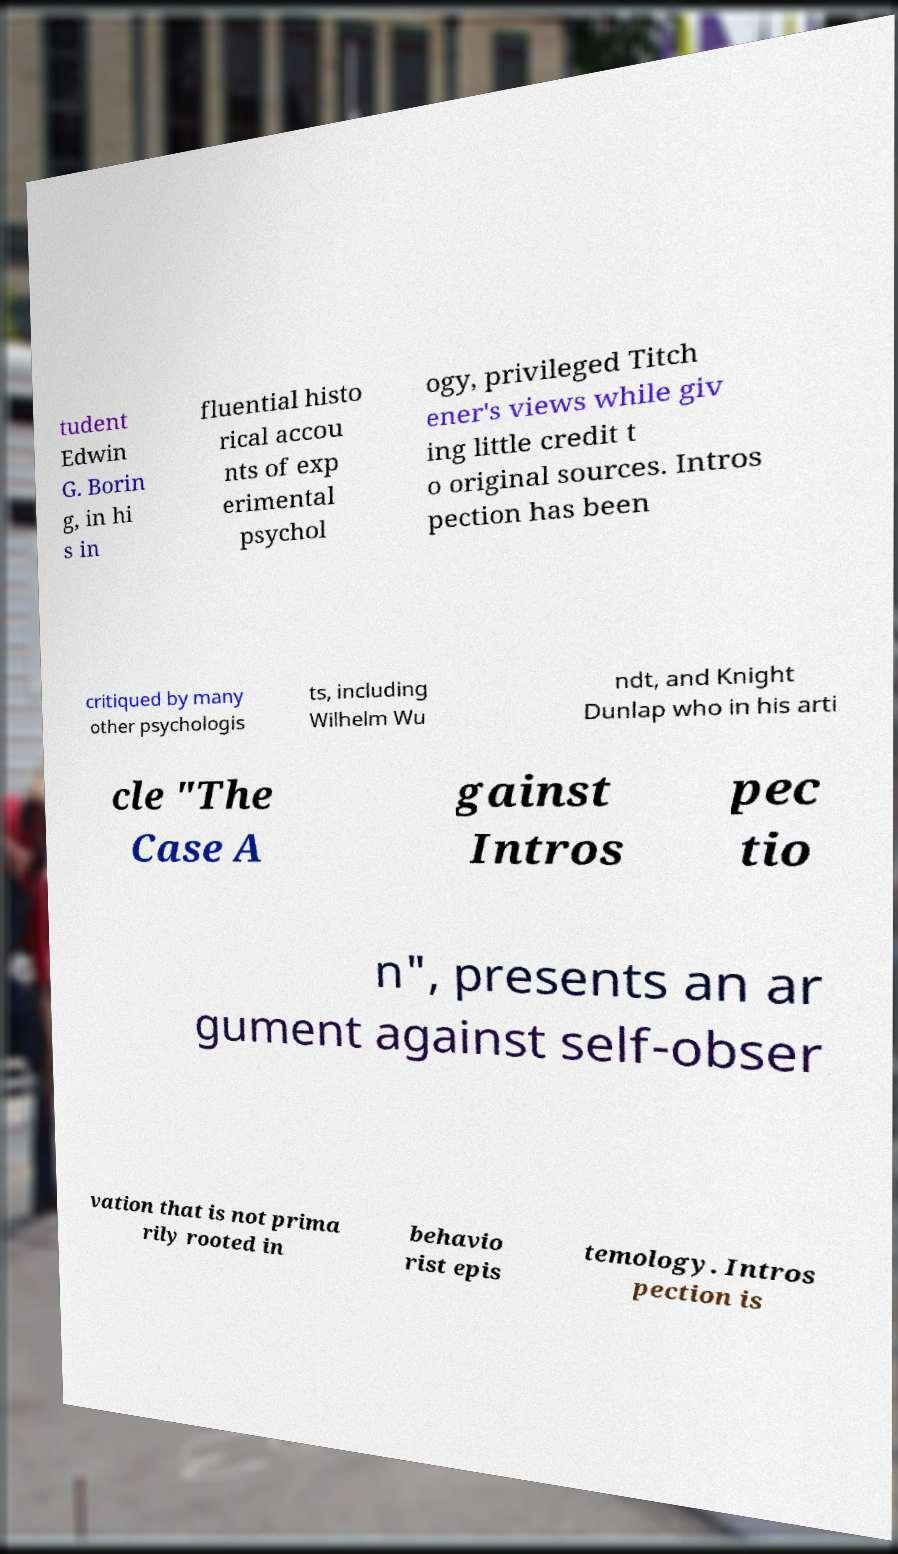For documentation purposes, I need the text within this image transcribed. Could you provide that? tudent Edwin G. Borin g, in hi s in fluential histo rical accou nts of exp erimental psychol ogy, privileged Titch ener's views while giv ing little credit t o original sources. Intros pection has been critiqued by many other psychologis ts, including Wilhelm Wu ndt, and Knight Dunlap who in his arti cle "The Case A gainst Intros pec tio n", presents an ar gument against self-obser vation that is not prima rily rooted in behavio rist epis temology. Intros pection is 